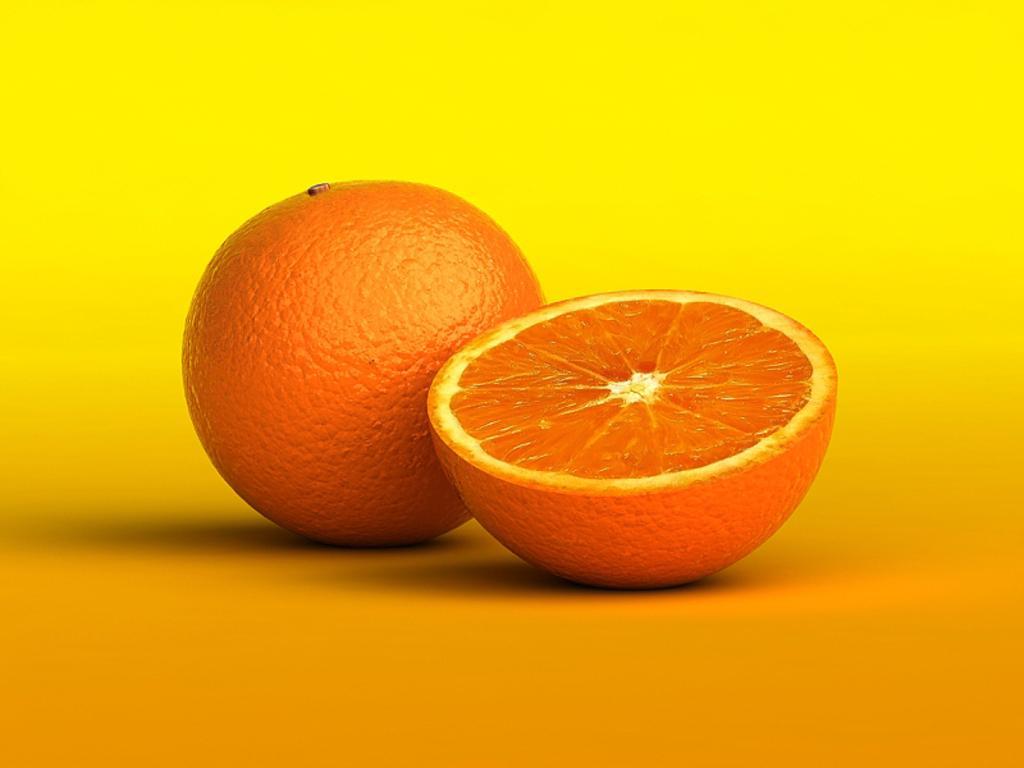Please provide a concise description of this image. We can see an orange and a slice of an orange on the orange surface. In the background it is yellow color. 